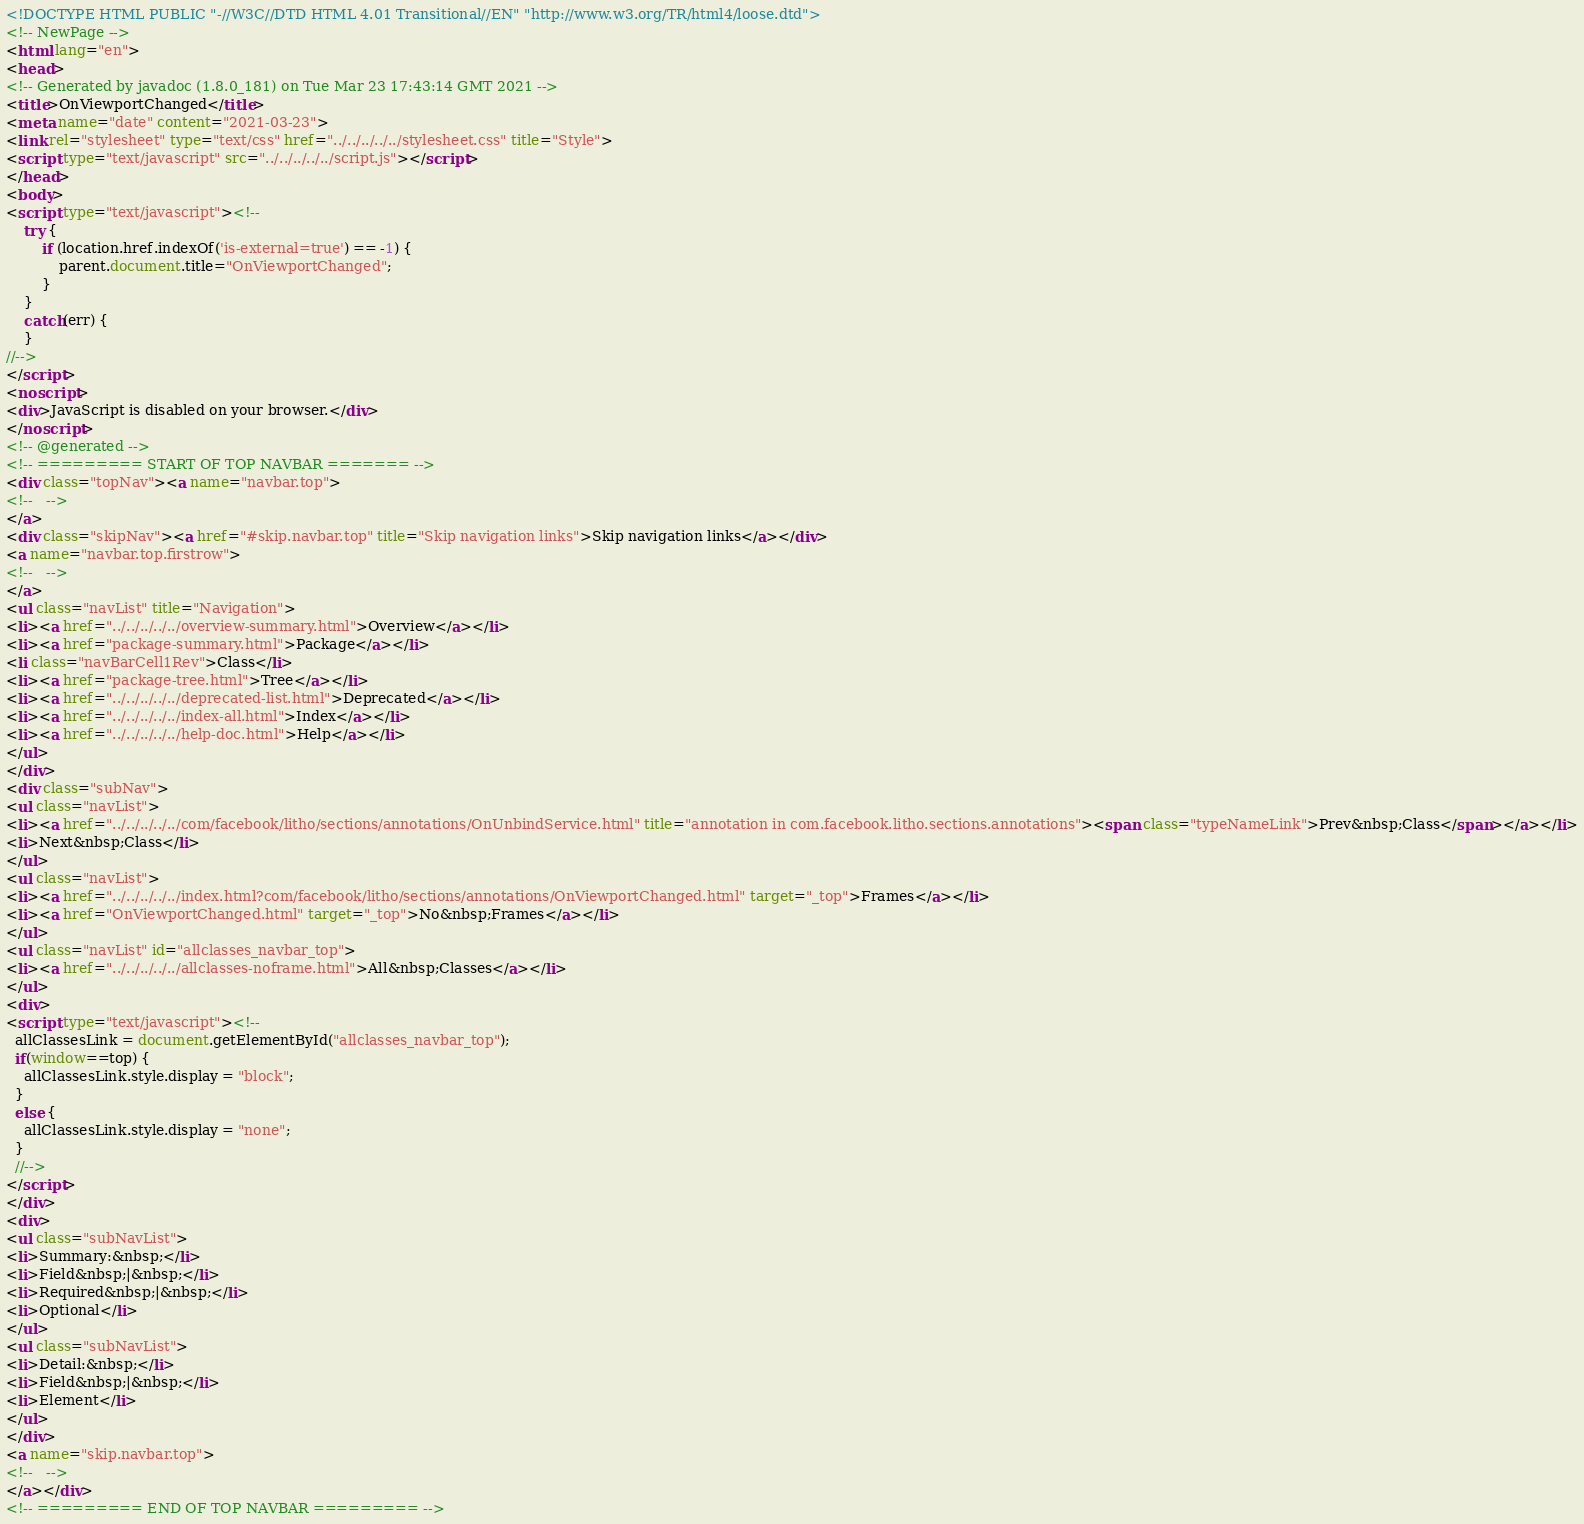<code> <loc_0><loc_0><loc_500><loc_500><_HTML_><!DOCTYPE HTML PUBLIC "-//W3C//DTD HTML 4.01 Transitional//EN" "http://www.w3.org/TR/html4/loose.dtd">
<!-- NewPage -->
<html lang="en">
<head>
<!-- Generated by javadoc (1.8.0_181) on Tue Mar 23 17:43:14 GMT 2021 -->
<title>OnViewportChanged</title>
<meta name="date" content="2021-03-23">
<link rel="stylesheet" type="text/css" href="../../../../../stylesheet.css" title="Style">
<script type="text/javascript" src="../../../../../script.js"></script>
</head>
<body>
<script type="text/javascript"><!--
    try {
        if (location.href.indexOf('is-external=true') == -1) {
            parent.document.title="OnViewportChanged";
        }
    }
    catch(err) {
    }
//-->
</script>
<noscript>
<div>JavaScript is disabled on your browser.</div>
</noscript>
<!-- @generated -->
<!-- ========= START OF TOP NAVBAR ======= -->
<div class="topNav"><a name="navbar.top">
<!--   -->
</a>
<div class="skipNav"><a href="#skip.navbar.top" title="Skip navigation links">Skip navigation links</a></div>
<a name="navbar.top.firstrow">
<!--   -->
</a>
<ul class="navList" title="Navigation">
<li><a href="../../../../../overview-summary.html">Overview</a></li>
<li><a href="package-summary.html">Package</a></li>
<li class="navBarCell1Rev">Class</li>
<li><a href="package-tree.html">Tree</a></li>
<li><a href="../../../../../deprecated-list.html">Deprecated</a></li>
<li><a href="../../../../../index-all.html">Index</a></li>
<li><a href="../../../../../help-doc.html">Help</a></li>
</ul>
</div>
<div class="subNav">
<ul class="navList">
<li><a href="../../../../../com/facebook/litho/sections/annotations/OnUnbindService.html" title="annotation in com.facebook.litho.sections.annotations"><span class="typeNameLink">Prev&nbsp;Class</span></a></li>
<li>Next&nbsp;Class</li>
</ul>
<ul class="navList">
<li><a href="../../../../../index.html?com/facebook/litho/sections/annotations/OnViewportChanged.html" target="_top">Frames</a></li>
<li><a href="OnViewportChanged.html" target="_top">No&nbsp;Frames</a></li>
</ul>
<ul class="navList" id="allclasses_navbar_top">
<li><a href="../../../../../allclasses-noframe.html">All&nbsp;Classes</a></li>
</ul>
<div>
<script type="text/javascript"><!--
  allClassesLink = document.getElementById("allclasses_navbar_top");
  if(window==top) {
    allClassesLink.style.display = "block";
  }
  else {
    allClassesLink.style.display = "none";
  }
  //-->
</script>
</div>
<div>
<ul class="subNavList">
<li>Summary:&nbsp;</li>
<li>Field&nbsp;|&nbsp;</li>
<li>Required&nbsp;|&nbsp;</li>
<li>Optional</li>
</ul>
<ul class="subNavList">
<li>Detail:&nbsp;</li>
<li>Field&nbsp;|&nbsp;</li>
<li>Element</li>
</ul>
</div>
<a name="skip.navbar.top">
<!--   -->
</a></div>
<!-- ========= END OF TOP NAVBAR ========= --></code> 